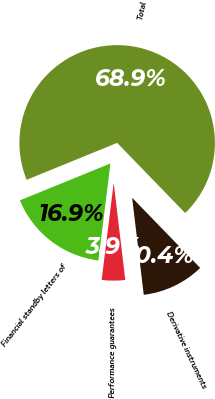Convert chart to OTSL. <chart><loc_0><loc_0><loc_500><loc_500><pie_chart><fcel>Financial standby letters of<fcel>Performance guarantees<fcel>Derivative instruments<fcel>Total<nl><fcel>16.87%<fcel>3.86%<fcel>10.36%<fcel>68.91%<nl></chart> 